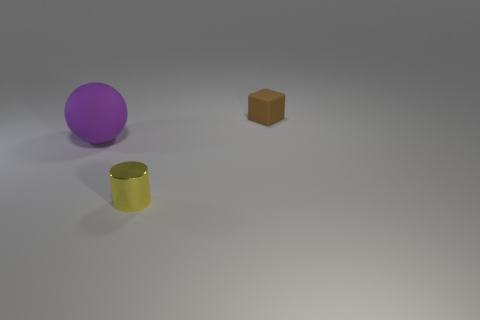Are there any other small yellow spheres made of the same material as the sphere?
Give a very brief answer. No. The cube has what color?
Your answer should be very brief. Brown. There is a tiny yellow object to the right of the big purple ball; does it have the same shape as the purple matte thing?
Your answer should be very brief. No. The small object behind the tiny thing that is in front of the object that is right of the small metallic thing is what shape?
Make the answer very short. Cube. What is the object that is behind the large matte ball made of?
Provide a short and direct response. Rubber. What color is the matte cube that is the same size as the cylinder?
Give a very brief answer. Brown. What number of other objects are there of the same shape as the large thing?
Your answer should be very brief. 0. Is the yellow object the same size as the block?
Give a very brief answer. Yes. Is the number of small brown blocks that are in front of the large purple thing greater than the number of small cubes that are in front of the tiny yellow object?
Provide a short and direct response. No. What number of other things are there of the same size as the brown rubber block?
Your answer should be compact. 1. 